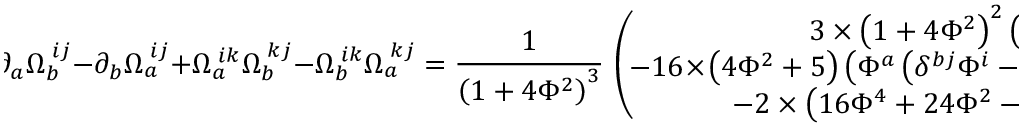<formula> <loc_0><loc_0><loc_500><loc_500>\, \partial _ { a } \Omega _ { b } ^ { \, i j } - \partial _ { b } \Omega _ { a } ^ { \, i j } + \Omega _ { a } ^ { \, i k } \Omega _ { b } ^ { \, k j } - \Omega _ { b } ^ { \, i k } \Omega _ { a } ^ { \, k j } = \frac { 1 } \left ( 1 + 4 \Phi ^ { 2 } \right ) ^ { 3 } } \, \left ( \, \begin{array} { c } { { 3 \times \left ( 1 + 4 \Phi ^ { 2 } \right ) ^ { 2 } \left ( \delta ^ { b j } \delta ^ { a i } - \delta ^ { b i } \delta ^ { a j } \right ) } } \\ { { - 1 6 \, \times \, \left ( 4 \Phi ^ { 2 } + 5 \right ) \left ( \Phi ^ { a } \left ( \delta ^ { b j } \Phi ^ { i } - \delta ^ { b i } \Phi ^ { j } \right ) - \Phi ^ { b } \, \left ( \delta ^ { a j } \Phi ^ { i } - \delta ^ { a i } \Phi ^ { j } \right ) \right ) } } \\ { { - 2 \times \left ( 1 6 \Phi ^ { 4 } + 2 4 \Phi ^ { 2 } - 1 1 \right ) \left ( \Phi ^ { a } \varepsilon ^ { b i j } - \Phi ^ { b } \varepsilon ^ { a i j } \right ) } } \end{array} \, \right ) \, .</formula> 